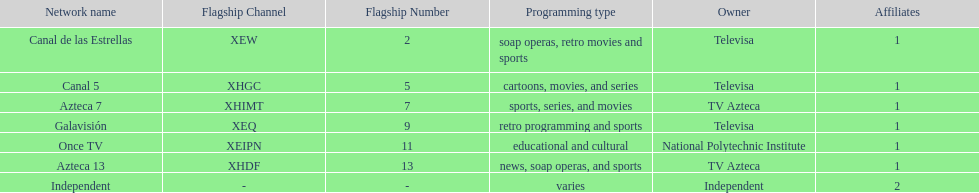What is the average number of affiliates that a given network will have? 1. 